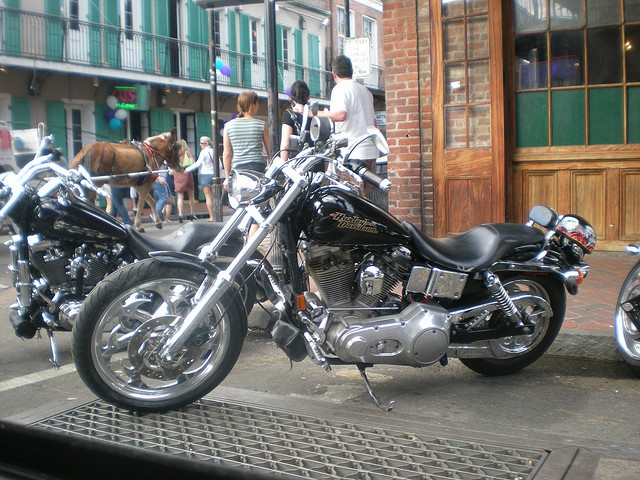Describe the objects in this image and their specific colors. I can see motorcycle in darkgray, gray, black, and white tones, motorcycle in darkgray, black, gray, and white tones, horse in darkgray, gray, maroon, and tan tones, people in darkgray, lightgray, and gray tones, and people in darkgray, lightgray, and gray tones in this image. 